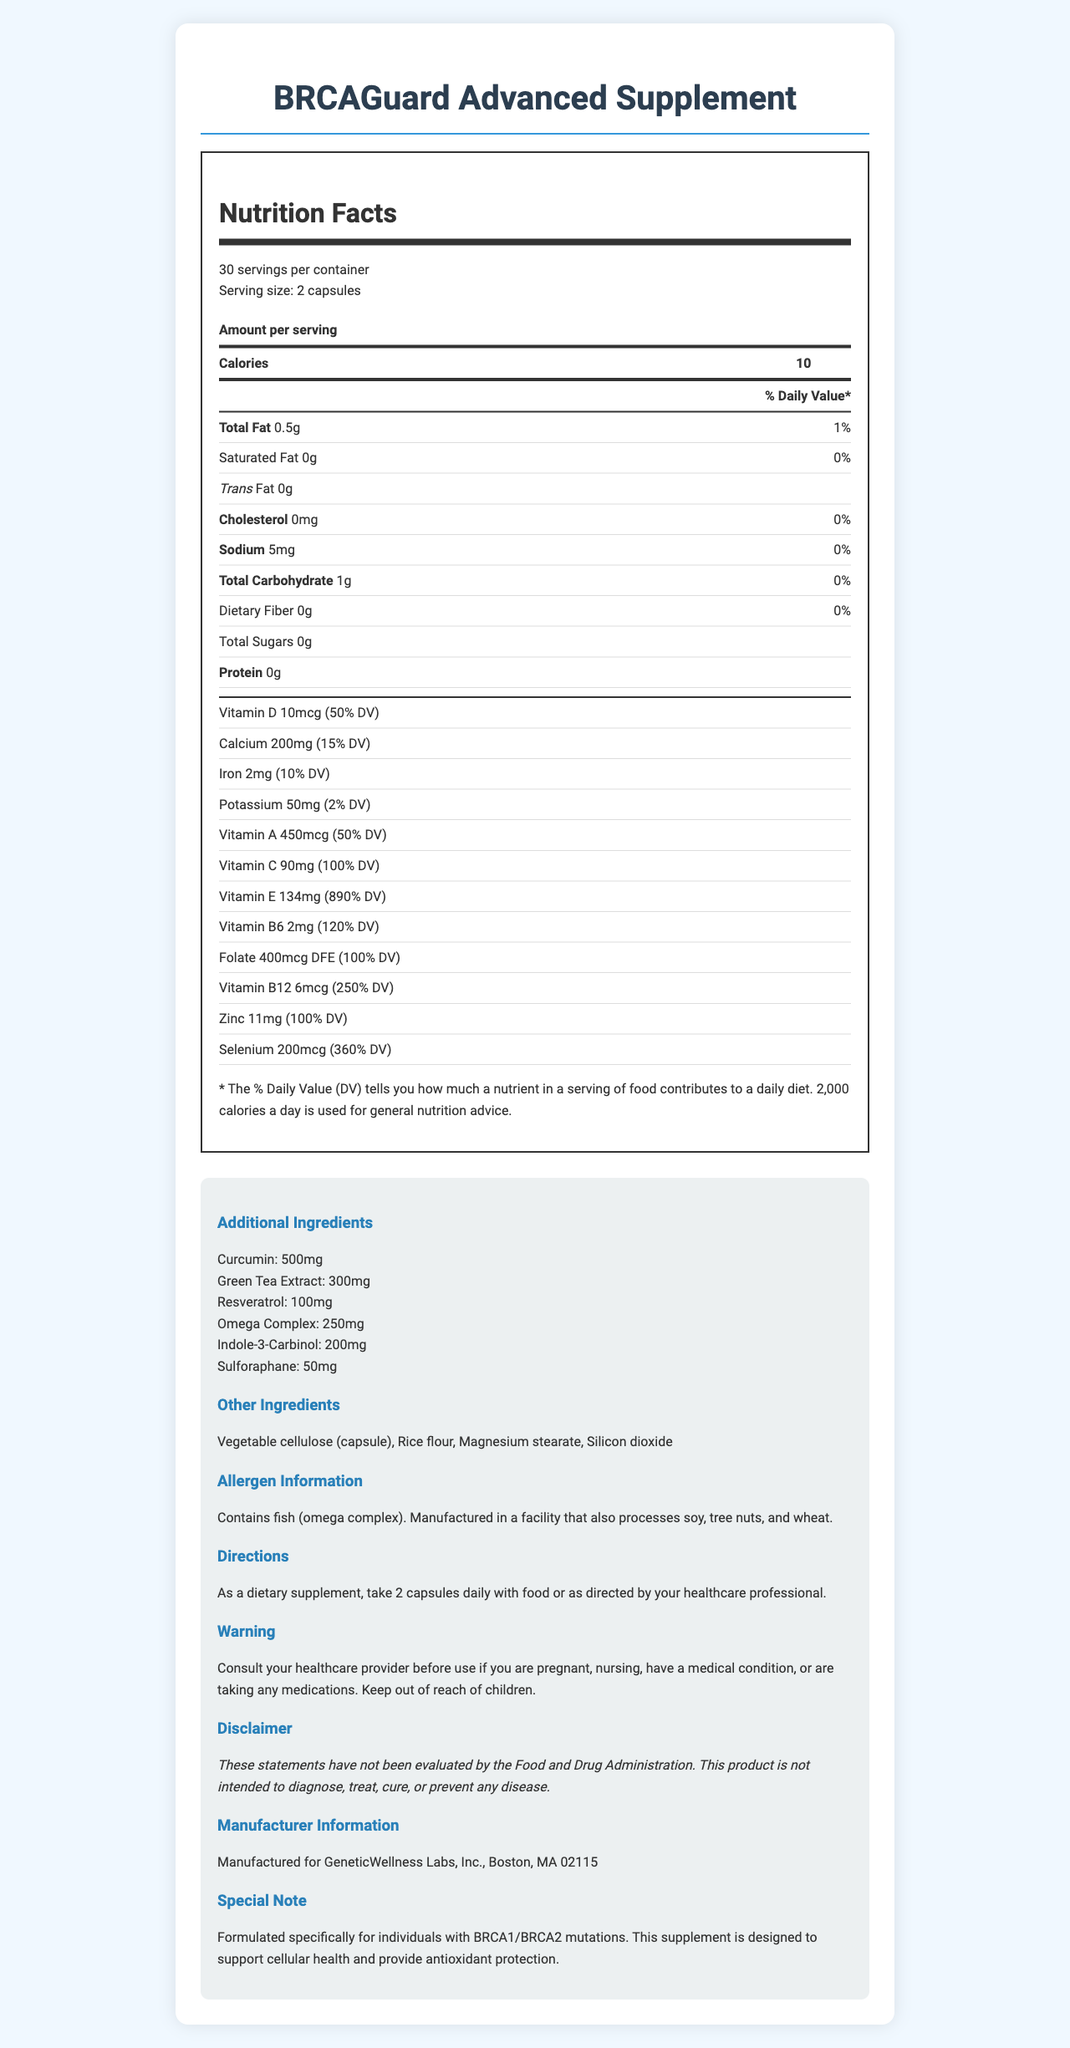what is the serving size for BRCAGuard Advanced Supplement? The serving size is mentioned in the document with the text "Serving size: 2 capsules".
Answer: 2 capsules how many calories are there per serving? The document clearly states "Calories: 10" under the Nutrition Facts section.
Answer: 10 how much vitamin E is in each serving? The document lists the amount of vitamin E per serving and its percentage daily value as "Vitamin E: 134mg (890% DV)".
Answer: 134mg (890% DV) what is the percentage daily value of vitamin C in each serving? The document specifies "Vitamin C: 90mg (100% DV)" under the Nutrition Facts section.
Answer: 100% how many milligrams of green tea extract are in each serving? The document mentions "Green Tea Extract: 300mg" in the Additional Ingredients section.
Answer: 300mg which of the following ingredients are included for antioxidant protection? A. Curcumin B. Green Tea Extract C. Resveratrol D. All of the above The document lists curcumin, green tea extract, and resveratrol as part of the additional ingredients known for their antioxidant properties.
Answer: D what is the approximate percentage of daily value of selenium provided in each serving? A. 100% B. 250% C. 360% D. 50% The document lists the selenium content as "Selenium: 200mcg (360% DV)".
Answer: C does this product contain any fish-derived ingredients? The Allergens Information section states "Contains fish (omega complex)".
Answer: Yes is this product suitable for people with soy allergies? The Allergen Information section indicates that the product is manufactured in a facility that processes soy.
Answer: No summarize the main purpose of this supplement. The detailed information provided about the ingredients, their quantities, and the specific note on the supplement's purpose helps derive the main idea.
Answer: The BRCAGuard Advanced Supplement is formulated specifically for individuals with BRCA1/BRCA2 mutations. It is designed to support cellular health and provide antioxidant protection. It includes various vitamins, minerals, and ingredients known for their health benefits. The supplement is intended for daily use. does the document provide information about the price of the supplement? The document does not mention the price of the supplement.
Answer: Not enough information 